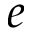<formula> <loc_0><loc_0><loc_500><loc_500>e</formula> 